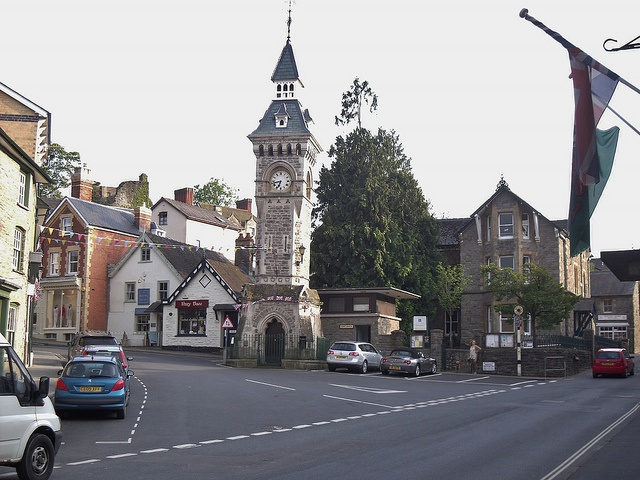Describe the objects in this image and their specific colors. I can see car in white, black, darkgray, gray, and lightgray tones, car in white, black, gray, navy, and blue tones, car in white, black, gray, darkgray, and lightgray tones, car in white, gray, black, and darkgray tones, and car in white, black, maroon, and gray tones in this image. 